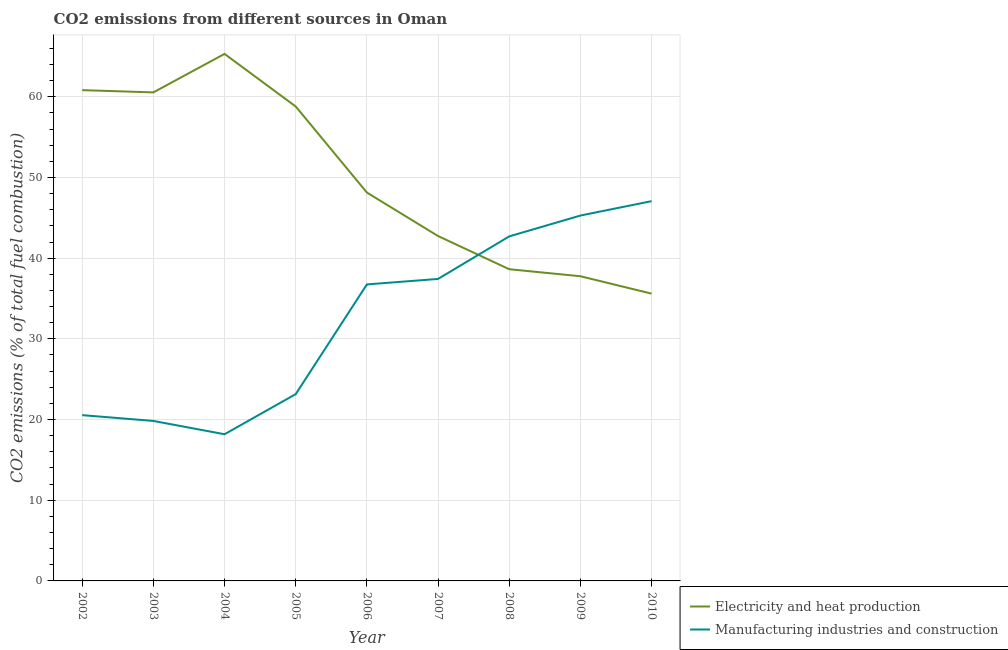What is the co2 emissions due to electricity and heat production in 2004?
Offer a terse response. 65.31. Across all years, what is the maximum co2 emissions due to manufacturing industries?
Keep it short and to the point. 47.06. Across all years, what is the minimum co2 emissions due to electricity and heat production?
Provide a short and direct response. 35.6. What is the total co2 emissions due to electricity and heat production in the graph?
Provide a short and direct response. 448.34. What is the difference between the co2 emissions due to electricity and heat production in 2002 and that in 2010?
Give a very brief answer. 25.22. What is the difference between the co2 emissions due to manufacturing industries in 2004 and the co2 emissions due to electricity and heat production in 2008?
Give a very brief answer. -20.45. What is the average co2 emissions due to manufacturing industries per year?
Keep it short and to the point. 32.32. In the year 2007, what is the difference between the co2 emissions due to manufacturing industries and co2 emissions due to electricity and heat production?
Your response must be concise. -5.31. In how many years, is the co2 emissions due to electricity and heat production greater than 60 %?
Provide a succinct answer. 3. What is the ratio of the co2 emissions due to manufacturing industries in 2005 to that in 2006?
Make the answer very short. 0.63. Is the co2 emissions due to manufacturing industries in 2006 less than that in 2007?
Your answer should be compact. Yes. Is the difference between the co2 emissions due to electricity and heat production in 2003 and 2006 greater than the difference between the co2 emissions due to manufacturing industries in 2003 and 2006?
Offer a very short reply. Yes. What is the difference between the highest and the second highest co2 emissions due to electricity and heat production?
Your answer should be very brief. 4.49. What is the difference between the highest and the lowest co2 emissions due to electricity and heat production?
Ensure brevity in your answer.  29.71. Is the sum of the co2 emissions due to manufacturing industries in 2003 and 2005 greater than the maximum co2 emissions due to electricity and heat production across all years?
Your answer should be compact. No. Does the co2 emissions due to electricity and heat production monotonically increase over the years?
Make the answer very short. No. Is the co2 emissions due to manufacturing industries strictly greater than the co2 emissions due to electricity and heat production over the years?
Provide a succinct answer. No. Is the co2 emissions due to manufacturing industries strictly less than the co2 emissions due to electricity and heat production over the years?
Keep it short and to the point. No. How are the legend labels stacked?
Offer a very short reply. Vertical. What is the title of the graph?
Your answer should be very brief. CO2 emissions from different sources in Oman. What is the label or title of the X-axis?
Offer a terse response. Year. What is the label or title of the Y-axis?
Offer a very short reply. CO2 emissions (% of total fuel combustion). What is the CO2 emissions (% of total fuel combustion) in Electricity and heat production in 2002?
Your answer should be compact. 60.82. What is the CO2 emissions (% of total fuel combustion) of Manufacturing industries and construction in 2002?
Make the answer very short. 20.55. What is the CO2 emissions (% of total fuel combustion) in Electricity and heat production in 2003?
Offer a very short reply. 60.54. What is the CO2 emissions (% of total fuel combustion) of Manufacturing industries and construction in 2003?
Give a very brief answer. 19.83. What is the CO2 emissions (% of total fuel combustion) of Electricity and heat production in 2004?
Provide a short and direct response. 65.31. What is the CO2 emissions (% of total fuel combustion) of Manufacturing industries and construction in 2004?
Provide a succinct answer. 18.18. What is the CO2 emissions (% of total fuel combustion) in Electricity and heat production in 2005?
Keep it short and to the point. 58.8. What is the CO2 emissions (% of total fuel combustion) of Manufacturing industries and construction in 2005?
Offer a very short reply. 23.15. What is the CO2 emissions (% of total fuel combustion) in Electricity and heat production in 2006?
Provide a short and direct response. 48.13. What is the CO2 emissions (% of total fuel combustion) in Manufacturing industries and construction in 2006?
Provide a short and direct response. 36.75. What is the CO2 emissions (% of total fuel combustion) of Electricity and heat production in 2007?
Your response must be concise. 42.74. What is the CO2 emissions (% of total fuel combustion) of Manufacturing industries and construction in 2007?
Give a very brief answer. 37.43. What is the CO2 emissions (% of total fuel combustion) in Electricity and heat production in 2008?
Provide a short and direct response. 38.63. What is the CO2 emissions (% of total fuel combustion) of Manufacturing industries and construction in 2008?
Make the answer very short. 42.7. What is the CO2 emissions (% of total fuel combustion) in Electricity and heat production in 2009?
Offer a terse response. 37.76. What is the CO2 emissions (% of total fuel combustion) of Manufacturing industries and construction in 2009?
Provide a succinct answer. 45.28. What is the CO2 emissions (% of total fuel combustion) in Electricity and heat production in 2010?
Your response must be concise. 35.6. What is the CO2 emissions (% of total fuel combustion) in Manufacturing industries and construction in 2010?
Your answer should be compact. 47.06. Across all years, what is the maximum CO2 emissions (% of total fuel combustion) in Electricity and heat production?
Your answer should be very brief. 65.31. Across all years, what is the maximum CO2 emissions (% of total fuel combustion) in Manufacturing industries and construction?
Provide a succinct answer. 47.06. Across all years, what is the minimum CO2 emissions (% of total fuel combustion) of Electricity and heat production?
Your answer should be very brief. 35.6. Across all years, what is the minimum CO2 emissions (% of total fuel combustion) in Manufacturing industries and construction?
Make the answer very short. 18.18. What is the total CO2 emissions (% of total fuel combustion) in Electricity and heat production in the graph?
Give a very brief answer. 448.34. What is the total CO2 emissions (% of total fuel combustion) of Manufacturing industries and construction in the graph?
Give a very brief answer. 290.92. What is the difference between the CO2 emissions (% of total fuel combustion) of Electricity and heat production in 2002 and that in 2003?
Offer a very short reply. 0.28. What is the difference between the CO2 emissions (% of total fuel combustion) of Manufacturing industries and construction in 2002 and that in 2003?
Offer a very short reply. 0.72. What is the difference between the CO2 emissions (% of total fuel combustion) of Electricity and heat production in 2002 and that in 2004?
Your response must be concise. -4.49. What is the difference between the CO2 emissions (% of total fuel combustion) of Manufacturing industries and construction in 2002 and that in 2004?
Ensure brevity in your answer.  2.37. What is the difference between the CO2 emissions (% of total fuel combustion) in Electricity and heat production in 2002 and that in 2005?
Provide a succinct answer. 2.03. What is the difference between the CO2 emissions (% of total fuel combustion) in Manufacturing industries and construction in 2002 and that in 2005?
Make the answer very short. -2.6. What is the difference between the CO2 emissions (% of total fuel combustion) in Electricity and heat production in 2002 and that in 2006?
Your response must be concise. 12.69. What is the difference between the CO2 emissions (% of total fuel combustion) in Manufacturing industries and construction in 2002 and that in 2006?
Make the answer very short. -16.2. What is the difference between the CO2 emissions (% of total fuel combustion) of Electricity and heat production in 2002 and that in 2007?
Make the answer very short. 18.08. What is the difference between the CO2 emissions (% of total fuel combustion) of Manufacturing industries and construction in 2002 and that in 2007?
Give a very brief answer. -16.88. What is the difference between the CO2 emissions (% of total fuel combustion) of Electricity and heat production in 2002 and that in 2008?
Make the answer very short. 22.19. What is the difference between the CO2 emissions (% of total fuel combustion) of Manufacturing industries and construction in 2002 and that in 2008?
Keep it short and to the point. -22.15. What is the difference between the CO2 emissions (% of total fuel combustion) of Electricity and heat production in 2002 and that in 2009?
Make the answer very short. 23.06. What is the difference between the CO2 emissions (% of total fuel combustion) in Manufacturing industries and construction in 2002 and that in 2009?
Your answer should be compact. -24.73. What is the difference between the CO2 emissions (% of total fuel combustion) of Electricity and heat production in 2002 and that in 2010?
Your response must be concise. 25.22. What is the difference between the CO2 emissions (% of total fuel combustion) of Manufacturing industries and construction in 2002 and that in 2010?
Provide a succinct answer. -26.52. What is the difference between the CO2 emissions (% of total fuel combustion) in Electricity and heat production in 2003 and that in 2004?
Provide a short and direct response. -4.77. What is the difference between the CO2 emissions (% of total fuel combustion) in Manufacturing industries and construction in 2003 and that in 2004?
Offer a very short reply. 1.65. What is the difference between the CO2 emissions (% of total fuel combustion) in Electricity and heat production in 2003 and that in 2005?
Your answer should be compact. 1.75. What is the difference between the CO2 emissions (% of total fuel combustion) in Manufacturing industries and construction in 2003 and that in 2005?
Provide a short and direct response. -3.32. What is the difference between the CO2 emissions (% of total fuel combustion) of Electricity and heat production in 2003 and that in 2006?
Give a very brief answer. 12.41. What is the difference between the CO2 emissions (% of total fuel combustion) in Manufacturing industries and construction in 2003 and that in 2006?
Offer a very short reply. -16.92. What is the difference between the CO2 emissions (% of total fuel combustion) in Electricity and heat production in 2003 and that in 2007?
Provide a succinct answer. 17.8. What is the difference between the CO2 emissions (% of total fuel combustion) of Manufacturing industries and construction in 2003 and that in 2007?
Your answer should be compact. -17.6. What is the difference between the CO2 emissions (% of total fuel combustion) in Electricity and heat production in 2003 and that in 2008?
Provide a succinct answer. 21.91. What is the difference between the CO2 emissions (% of total fuel combustion) of Manufacturing industries and construction in 2003 and that in 2008?
Your response must be concise. -22.87. What is the difference between the CO2 emissions (% of total fuel combustion) of Electricity and heat production in 2003 and that in 2009?
Your answer should be very brief. 22.79. What is the difference between the CO2 emissions (% of total fuel combustion) in Manufacturing industries and construction in 2003 and that in 2009?
Make the answer very short. -25.45. What is the difference between the CO2 emissions (% of total fuel combustion) in Electricity and heat production in 2003 and that in 2010?
Your response must be concise. 24.94. What is the difference between the CO2 emissions (% of total fuel combustion) of Manufacturing industries and construction in 2003 and that in 2010?
Provide a short and direct response. -27.24. What is the difference between the CO2 emissions (% of total fuel combustion) of Electricity and heat production in 2004 and that in 2005?
Ensure brevity in your answer.  6.52. What is the difference between the CO2 emissions (% of total fuel combustion) of Manufacturing industries and construction in 2004 and that in 2005?
Your answer should be compact. -4.97. What is the difference between the CO2 emissions (% of total fuel combustion) of Electricity and heat production in 2004 and that in 2006?
Make the answer very short. 17.18. What is the difference between the CO2 emissions (% of total fuel combustion) in Manufacturing industries and construction in 2004 and that in 2006?
Your answer should be compact. -18.57. What is the difference between the CO2 emissions (% of total fuel combustion) in Electricity and heat production in 2004 and that in 2007?
Offer a terse response. 22.57. What is the difference between the CO2 emissions (% of total fuel combustion) of Manufacturing industries and construction in 2004 and that in 2007?
Provide a short and direct response. -19.25. What is the difference between the CO2 emissions (% of total fuel combustion) in Electricity and heat production in 2004 and that in 2008?
Offer a terse response. 26.68. What is the difference between the CO2 emissions (% of total fuel combustion) in Manufacturing industries and construction in 2004 and that in 2008?
Give a very brief answer. -24.52. What is the difference between the CO2 emissions (% of total fuel combustion) in Electricity and heat production in 2004 and that in 2009?
Make the answer very short. 27.56. What is the difference between the CO2 emissions (% of total fuel combustion) of Manufacturing industries and construction in 2004 and that in 2009?
Make the answer very short. -27.1. What is the difference between the CO2 emissions (% of total fuel combustion) in Electricity and heat production in 2004 and that in 2010?
Make the answer very short. 29.71. What is the difference between the CO2 emissions (% of total fuel combustion) of Manufacturing industries and construction in 2004 and that in 2010?
Your answer should be very brief. -28.89. What is the difference between the CO2 emissions (% of total fuel combustion) of Electricity and heat production in 2005 and that in 2006?
Ensure brevity in your answer.  10.66. What is the difference between the CO2 emissions (% of total fuel combustion) of Manufacturing industries and construction in 2005 and that in 2006?
Keep it short and to the point. -13.6. What is the difference between the CO2 emissions (% of total fuel combustion) of Electricity and heat production in 2005 and that in 2007?
Your answer should be compact. 16.06. What is the difference between the CO2 emissions (% of total fuel combustion) in Manufacturing industries and construction in 2005 and that in 2007?
Provide a succinct answer. -14.28. What is the difference between the CO2 emissions (% of total fuel combustion) in Electricity and heat production in 2005 and that in 2008?
Offer a very short reply. 20.17. What is the difference between the CO2 emissions (% of total fuel combustion) of Manufacturing industries and construction in 2005 and that in 2008?
Your answer should be very brief. -19.55. What is the difference between the CO2 emissions (% of total fuel combustion) in Electricity and heat production in 2005 and that in 2009?
Make the answer very short. 21.04. What is the difference between the CO2 emissions (% of total fuel combustion) of Manufacturing industries and construction in 2005 and that in 2009?
Your response must be concise. -22.13. What is the difference between the CO2 emissions (% of total fuel combustion) of Electricity and heat production in 2005 and that in 2010?
Your answer should be very brief. 23.19. What is the difference between the CO2 emissions (% of total fuel combustion) of Manufacturing industries and construction in 2005 and that in 2010?
Your answer should be compact. -23.92. What is the difference between the CO2 emissions (% of total fuel combustion) in Electricity and heat production in 2006 and that in 2007?
Provide a short and direct response. 5.39. What is the difference between the CO2 emissions (% of total fuel combustion) of Manufacturing industries and construction in 2006 and that in 2007?
Your answer should be very brief. -0.68. What is the difference between the CO2 emissions (% of total fuel combustion) in Electricity and heat production in 2006 and that in 2008?
Your answer should be compact. 9.5. What is the difference between the CO2 emissions (% of total fuel combustion) in Manufacturing industries and construction in 2006 and that in 2008?
Offer a terse response. -5.95. What is the difference between the CO2 emissions (% of total fuel combustion) in Electricity and heat production in 2006 and that in 2009?
Your answer should be very brief. 10.37. What is the difference between the CO2 emissions (% of total fuel combustion) of Manufacturing industries and construction in 2006 and that in 2009?
Offer a terse response. -8.53. What is the difference between the CO2 emissions (% of total fuel combustion) in Electricity and heat production in 2006 and that in 2010?
Give a very brief answer. 12.53. What is the difference between the CO2 emissions (% of total fuel combustion) in Manufacturing industries and construction in 2006 and that in 2010?
Your answer should be very brief. -10.32. What is the difference between the CO2 emissions (% of total fuel combustion) of Electricity and heat production in 2007 and that in 2008?
Make the answer very short. 4.11. What is the difference between the CO2 emissions (% of total fuel combustion) of Manufacturing industries and construction in 2007 and that in 2008?
Make the answer very short. -5.27. What is the difference between the CO2 emissions (% of total fuel combustion) of Electricity and heat production in 2007 and that in 2009?
Offer a terse response. 4.98. What is the difference between the CO2 emissions (% of total fuel combustion) in Manufacturing industries and construction in 2007 and that in 2009?
Give a very brief answer. -7.85. What is the difference between the CO2 emissions (% of total fuel combustion) of Electricity and heat production in 2007 and that in 2010?
Keep it short and to the point. 7.14. What is the difference between the CO2 emissions (% of total fuel combustion) in Manufacturing industries and construction in 2007 and that in 2010?
Ensure brevity in your answer.  -9.64. What is the difference between the CO2 emissions (% of total fuel combustion) of Electricity and heat production in 2008 and that in 2009?
Keep it short and to the point. 0.87. What is the difference between the CO2 emissions (% of total fuel combustion) in Manufacturing industries and construction in 2008 and that in 2009?
Provide a succinct answer. -2.58. What is the difference between the CO2 emissions (% of total fuel combustion) in Electricity and heat production in 2008 and that in 2010?
Your answer should be compact. 3.03. What is the difference between the CO2 emissions (% of total fuel combustion) in Manufacturing industries and construction in 2008 and that in 2010?
Offer a terse response. -4.37. What is the difference between the CO2 emissions (% of total fuel combustion) in Electricity and heat production in 2009 and that in 2010?
Your answer should be very brief. 2.16. What is the difference between the CO2 emissions (% of total fuel combustion) of Manufacturing industries and construction in 2009 and that in 2010?
Your answer should be very brief. -1.78. What is the difference between the CO2 emissions (% of total fuel combustion) of Electricity and heat production in 2002 and the CO2 emissions (% of total fuel combustion) of Manufacturing industries and construction in 2003?
Offer a very short reply. 41. What is the difference between the CO2 emissions (% of total fuel combustion) of Electricity and heat production in 2002 and the CO2 emissions (% of total fuel combustion) of Manufacturing industries and construction in 2004?
Make the answer very short. 42.64. What is the difference between the CO2 emissions (% of total fuel combustion) in Electricity and heat production in 2002 and the CO2 emissions (% of total fuel combustion) in Manufacturing industries and construction in 2005?
Give a very brief answer. 37.67. What is the difference between the CO2 emissions (% of total fuel combustion) in Electricity and heat production in 2002 and the CO2 emissions (% of total fuel combustion) in Manufacturing industries and construction in 2006?
Offer a terse response. 24.08. What is the difference between the CO2 emissions (% of total fuel combustion) in Electricity and heat production in 2002 and the CO2 emissions (% of total fuel combustion) in Manufacturing industries and construction in 2007?
Make the answer very short. 23.4. What is the difference between the CO2 emissions (% of total fuel combustion) in Electricity and heat production in 2002 and the CO2 emissions (% of total fuel combustion) in Manufacturing industries and construction in 2008?
Offer a terse response. 18.12. What is the difference between the CO2 emissions (% of total fuel combustion) in Electricity and heat production in 2002 and the CO2 emissions (% of total fuel combustion) in Manufacturing industries and construction in 2009?
Offer a very short reply. 15.54. What is the difference between the CO2 emissions (% of total fuel combustion) of Electricity and heat production in 2002 and the CO2 emissions (% of total fuel combustion) of Manufacturing industries and construction in 2010?
Offer a very short reply. 13.76. What is the difference between the CO2 emissions (% of total fuel combustion) of Electricity and heat production in 2003 and the CO2 emissions (% of total fuel combustion) of Manufacturing industries and construction in 2004?
Ensure brevity in your answer.  42.37. What is the difference between the CO2 emissions (% of total fuel combustion) of Electricity and heat production in 2003 and the CO2 emissions (% of total fuel combustion) of Manufacturing industries and construction in 2005?
Give a very brief answer. 37.4. What is the difference between the CO2 emissions (% of total fuel combustion) of Electricity and heat production in 2003 and the CO2 emissions (% of total fuel combustion) of Manufacturing industries and construction in 2006?
Keep it short and to the point. 23.8. What is the difference between the CO2 emissions (% of total fuel combustion) of Electricity and heat production in 2003 and the CO2 emissions (% of total fuel combustion) of Manufacturing industries and construction in 2007?
Make the answer very short. 23.12. What is the difference between the CO2 emissions (% of total fuel combustion) in Electricity and heat production in 2003 and the CO2 emissions (% of total fuel combustion) in Manufacturing industries and construction in 2008?
Your answer should be compact. 17.84. What is the difference between the CO2 emissions (% of total fuel combustion) in Electricity and heat production in 2003 and the CO2 emissions (% of total fuel combustion) in Manufacturing industries and construction in 2009?
Your answer should be compact. 15.26. What is the difference between the CO2 emissions (% of total fuel combustion) in Electricity and heat production in 2003 and the CO2 emissions (% of total fuel combustion) in Manufacturing industries and construction in 2010?
Your answer should be compact. 13.48. What is the difference between the CO2 emissions (% of total fuel combustion) of Electricity and heat production in 2004 and the CO2 emissions (% of total fuel combustion) of Manufacturing industries and construction in 2005?
Ensure brevity in your answer.  42.17. What is the difference between the CO2 emissions (% of total fuel combustion) in Electricity and heat production in 2004 and the CO2 emissions (% of total fuel combustion) in Manufacturing industries and construction in 2006?
Offer a terse response. 28.57. What is the difference between the CO2 emissions (% of total fuel combustion) in Electricity and heat production in 2004 and the CO2 emissions (% of total fuel combustion) in Manufacturing industries and construction in 2007?
Give a very brief answer. 27.89. What is the difference between the CO2 emissions (% of total fuel combustion) of Electricity and heat production in 2004 and the CO2 emissions (% of total fuel combustion) of Manufacturing industries and construction in 2008?
Your answer should be very brief. 22.61. What is the difference between the CO2 emissions (% of total fuel combustion) in Electricity and heat production in 2004 and the CO2 emissions (% of total fuel combustion) in Manufacturing industries and construction in 2009?
Give a very brief answer. 20.03. What is the difference between the CO2 emissions (% of total fuel combustion) of Electricity and heat production in 2004 and the CO2 emissions (% of total fuel combustion) of Manufacturing industries and construction in 2010?
Offer a terse response. 18.25. What is the difference between the CO2 emissions (% of total fuel combustion) of Electricity and heat production in 2005 and the CO2 emissions (% of total fuel combustion) of Manufacturing industries and construction in 2006?
Make the answer very short. 22.05. What is the difference between the CO2 emissions (% of total fuel combustion) in Electricity and heat production in 2005 and the CO2 emissions (% of total fuel combustion) in Manufacturing industries and construction in 2007?
Your answer should be compact. 21.37. What is the difference between the CO2 emissions (% of total fuel combustion) of Electricity and heat production in 2005 and the CO2 emissions (% of total fuel combustion) of Manufacturing industries and construction in 2008?
Provide a succinct answer. 16.1. What is the difference between the CO2 emissions (% of total fuel combustion) of Electricity and heat production in 2005 and the CO2 emissions (% of total fuel combustion) of Manufacturing industries and construction in 2009?
Keep it short and to the point. 13.52. What is the difference between the CO2 emissions (% of total fuel combustion) in Electricity and heat production in 2005 and the CO2 emissions (% of total fuel combustion) in Manufacturing industries and construction in 2010?
Keep it short and to the point. 11.73. What is the difference between the CO2 emissions (% of total fuel combustion) in Electricity and heat production in 2006 and the CO2 emissions (% of total fuel combustion) in Manufacturing industries and construction in 2007?
Make the answer very short. 10.71. What is the difference between the CO2 emissions (% of total fuel combustion) of Electricity and heat production in 2006 and the CO2 emissions (% of total fuel combustion) of Manufacturing industries and construction in 2008?
Give a very brief answer. 5.43. What is the difference between the CO2 emissions (% of total fuel combustion) in Electricity and heat production in 2006 and the CO2 emissions (% of total fuel combustion) in Manufacturing industries and construction in 2009?
Your answer should be compact. 2.85. What is the difference between the CO2 emissions (% of total fuel combustion) in Electricity and heat production in 2006 and the CO2 emissions (% of total fuel combustion) in Manufacturing industries and construction in 2010?
Provide a succinct answer. 1.07. What is the difference between the CO2 emissions (% of total fuel combustion) in Electricity and heat production in 2007 and the CO2 emissions (% of total fuel combustion) in Manufacturing industries and construction in 2008?
Provide a short and direct response. 0.04. What is the difference between the CO2 emissions (% of total fuel combustion) of Electricity and heat production in 2007 and the CO2 emissions (% of total fuel combustion) of Manufacturing industries and construction in 2009?
Offer a very short reply. -2.54. What is the difference between the CO2 emissions (% of total fuel combustion) in Electricity and heat production in 2007 and the CO2 emissions (% of total fuel combustion) in Manufacturing industries and construction in 2010?
Your answer should be compact. -4.33. What is the difference between the CO2 emissions (% of total fuel combustion) in Electricity and heat production in 2008 and the CO2 emissions (% of total fuel combustion) in Manufacturing industries and construction in 2009?
Give a very brief answer. -6.65. What is the difference between the CO2 emissions (% of total fuel combustion) in Electricity and heat production in 2008 and the CO2 emissions (% of total fuel combustion) in Manufacturing industries and construction in 2010?
Provide a succinct answer. -8.44. What is the difference between the CO2 emissions (% of total fuel combustion) in Electricity and heat production in 2009 and the CO2 emissions (% of total fuel combustion) in Manufacturing industries and construction in 2010?
Your answer should be very brief. -9.31. What is the average CO2 emissions (% of total fuel combustion) in Electricity and heat production per year?
Provide a succinct answer. 49.82. What is the average CO2 emissions (% of total fuel combustion) of Manufacturing industries and construction per year?
Make the answer very short. 32.32. In the year 2002, what is the difference between the CO2 emissions (% of total fuel combustion) in Electricity and heat production and CO2 emissions (% of total fuel combustion) in Manufacturing industries and construction?
Make the answer very short. 40.28. In the year 2003, what is the difference between the CO2 emissions (% of total fuel combustion) of Electricity and heat production and CO2 emissions (% of total fuel combustion) of Manufacturing industries and construction?
Keep it short and to the point. 40.72. In the year 2004, what is the difference between the CO2 emissions (% of total fuel combustion) in Electricity and heat production and CO2 emissions (% of total fuel combustion) in Manufacturing industries and construction?
Your response must be concise. 47.14. In the year 2005, what is the difference between the CO2 emissions (% of total fuel combustion) of Electricity and heat production and CO2 emissions (% of total fuel combustion) of Manufacturing industries and construction?
Give a very brief answer. 35.65. In the year 2006, what is the difference between the CO2 emissions (% of total fuel combustion) in Electricity and heat production and CO2 emissions (% of total fuel combustion) in Manufacturing industries and construction?
Your response must be concise. 11.39. In the year 2007, what is the difference between the CO2 emissions (% of total fuel combustion) in Electricity and heat production and CO2 emissions (% of total fuel combustion) in Manufacturing industries and construction?
Your response must be concise. 5.31. In the year 2008, what is the difference between the CO2 emissions (% of total fuel combustion) in Electricity and heat production and CO2 emissions (% of total fuel combustion) in Manufacturing industries and construction?
Provide a short and direct response. -4.07. In the year 2009, what is the difference between the CO2 emissions (% of total fuel combustion) in Electricity and heat production and CO2 emissions (% of total fuel combustion) in Manufacturing industries and construction?
Ensure brevity in your answer.  -7.52. In the year 2010, what is the difference between the CO2 emissions (% of total fuel combustion) in Electricity and heat production and CO2 emissions (% of total fuel combustion) in Manufacturing industries and construction?
Ensure brevity in your answer.  -11.46. What is the ratio of the CO2 emissions (% of total fuel combustion) of Electricity and heat production in 2002 to that in 2003?
Your response must be concise. 1. What is the ratio of the CO2 emissions (% of total fuel combustion) in Manufacturing industries and construction in 2002 to that in 2003?
Offer a terse response. 1.04. What is the ratio of the CO2 emissions (% of total fuel combustion) of Electricity and heat production in 2002 to that in 2004?
Give a very brief answer. 0.93. What is the ratio of the CO2 emissions (% of total fuel combustion) of Manufacturing industries and construction in 2002 to that in 2004?
Keep it short and to the point. 1.13. What is the ratio of the CO2 emissions (% of total fuel combustion) of Electricity and heat production in 2002 to that in 2005?
Your answer should be very brief. 1.03. What is the ratio of the CO2 emissions (% of total fuel combustion) in Manufacturing industries and construction in 2002 to that in 2005?
Offer a terse response. 0.89. What is the ratio of the CO2 emissions (% of total fuel combustion) in Electricity and heat production in 2002 to that in 2006?
Make the answer very short. 1.26. What is the ratio of the CO2 emissions (% of total fuel combustion) in Manufacturing industries and construction in 2002 to that in 2006?
Keep it short and to the point. 0.56. What is the ratio of the CO2 emissions (% of total fuel combustion) in Electricity and heat production in 2002 to that in 2007?
Give a very brief answer. 1.42. What is the ratio of the CO2 emissions (% of total fuel combustion) in Manufacturing industries and construction in 2002 to that in 2007?
Give a very brief answer. 0.55. What is the ratio of the CO2 emissions (% of total fuel combustion) in Electricity and heat production in 2002 to that in 2008?
Offer a very short reply. 1.57. What is the ratio of the CO2 emissions (% of total fuel combustion) in Manufacturing industries and construction in 2002 to that in 2008?
Make the answer very short. 0.48. What is the ratio of the CO2 emissions (% of total fuel combustion) in Electricity and heat production in 2002 to that in 2009?
Your answer should be compact. 1.61. What is the ratio of the CO2 emissions (% of total fuel combustion) of Manufacturing industries and construction in 2002 to that in 2009?
Your response must be concise. 0.45. What is the ratio of the CO2 emissions (% of total fuel combustion) in Electricity and heat production in 2002 to that in 2010?
Offer a terse response. 1.71. What is the ratio of the CO2 emissions (% of total fuel combustion) of Manufacturing industries and construction in 2002 to that in 2010?
Provide a succinct answer. 0.44. What is the ratio of the CO2 emissions (% of total fuel combustion) in Electricity and heat production in 2003 to that in 2004?
Offer a terse response. 0.93. What is the ratio of the CO2 emissions (% of total fuel combustion) of Manufacturing industries and construction in 2003 to that in 2004?
Give a very brief answer. 1.09. What is the ratio of the CO2 emissions (% of total fuel combustion) in Electricity and heat production in 2003 to that in 2005?
Your answer should be compact. 1.03. What is the ratio of the CO2 emissions (% of total fuel combustion) in Manufacturing industries and construction in 2003 to that in 2005?
Give a very brief answer. 0.86. What is the ratio of the CO2 emissions (% of total fuel combustion) of Electricity and heat production in 2003 to that in 2006?
Your response must be concise. 1.26. What is the ratio of the CO2 emissions (% of total fuel combustion) of Manufacturing industries and construction in 2003 to that in 2006?
Your answer should be compact. 0.54. What is the ratio of the CO2 emissions (% of total fuel combustion) in Electricity and heat production in 2003 to that in 2007?
Your answer should be very brief. 1.42. What is the ratio of the CO2 emissions (% of total fuel combustion) of Manufacturing industries and construction in 2003 to that in 2007?
Ensure brevity in your answer.  0.53. What is the ratio of the CO2 emissions (% of total fuel combustion) of Electricity and heat production in 2003 to that in 2008?
Your answer should be very brief. 1.57. What is the ratio of the CO2 emissions (% of total fuel combustion) in Manufacturing industries and construction in 2003 to that in 2008?
Provide a short and direct response. 0.46. What is the ratio of the CO2 emissions (% of total fuel combustion) of Electricity and heat production in 2003 to that in 2009?
Your answer should be compact. 1.6. What is the ratio of the CO2 emissions (% of total fuel combustion) in Manufacturing industries and construction in 2003 to that in 2009?
Your response must be concise. 0.44. What is the ratio of the CO2 emissions (% of total fuel combustion) of Electricity and heat production in 2003 to that in 2010?
Offer a terse response. 1.7. What is the ratio of the CO2 emissions (% of total fuel combustion) in Manufacturing industries and construction in 2003 to that in 2010?
Offer a very short reply. 0.42. What is the ratio of the CO2 emissions (% of total fuel combustion) of Electricity and heat production in 2004 to that in 2005?
Your answer should be very brief. 1.11. What is the ratio of the CO2 emissions (% of total fuel combustion) of Manufacturing industries and construction in 2004 to that in 2005?
Keep it short and to the point. 0.79. What is the ratio of the CO2 emissions (% of total fuel combustion) of Electricity and heat production in 2004 to that in 2006?
Make the answer very short. 1.36. What is the ratio of the CO2 emissions (% of total fuel combustion) in Manufacturing industries and construction in 2004 to that in 2006?
Your answer should be compact. 0.49. What is the ratio of the CO2 emissions (% of total fuel combustion) in Electricity and heat production in 2004 to that in 2007?
Provide a succinct answer. 1.53. What is the ratio of the CO2 emissions (% of total fuel combustion) of Manufacturing industries and construction in 2004 to that in 2007?
Your response must be concise. 0.49. What is the ratio of the CO2 emissions (% of total fuel combustion) in Electricity and heat production in 2004 to that in 2008?
Your response must be concise. 1.69. What is the ratio of the CO2 emissions (% of total fuel combustion) in Manufacturing industries and construction in 2004 to that in 2008?
Offer a terse response. 0.43. What is the ratio of the CO2 emissions (% of total fuel combustion) of Electricity and heat production in 2004 to that in 2009?
Keep it short and to the point. 1.73. What is the ratio of the CO2 emissions (% of total fuel combustion) in Manufacturing industries and construction in 2004 to that in 2009?
Your answer should be compact. 0.4. What is the ratio of the CO2 emissions (% of total fuel combustion) in Electricity and heat production in 2004 to that in 2010?
Keep it short and to the point. 1.83. What is the ratio of the CO2 emissions (% of total fuel combustion) of Manufacturing industries and construction in 2004 to that in 2010?
Your answer should be very brief. 0.39. What is the ratio of the CO2 emissions (% of total fuel combustion) of Electricity and heat production in 2005 to that in 2006?
Your answer should be very brief. 1.22. What is the ratio of the CO2 emissions (% of total fuel combustion) of Manufacturing industries and construction in 2005 to that in 2006?
Ensure brevity in your answer.  0.63. What is the ratio of the CO2 emissions (% of total fuel combustion) in Electricity and heat production in 2005 to that in 2007?
Give a very brief answer. 1.38. What is the ratio of the CO2 emissions (% of total fuel combustion) of Manufacturing industries and construction in 2005 to that in 2007?
Offer a very short reply. 0.62. What is the ratio of the CO2 emissions (% of total fuel combustion) of Electricity and heat production in 2005 to that in 2008?
Give a very brief answer. 1.52. What is the ratio of the CO2 emissions (% of total fuel combustion) of Manufacturing industries and construction in 2005 to that in 2008?
Your response must be concise. 0.54. What is the ratio of the CO2 emissions (% of total fuel combustion) in Electricity and heat production in 2005 to that in 2009?
Your answer should be very brief. 1.56. What is the ratio of the CO2 emissions (% of total fuel combustion) of Manufacturing industries and construction in 2005 to that in 2009?
Make the answer very short. 0.51. What is the ratio of the CO2 emissions (% of total fuel combustion) in Electricity and heat production in 2005 to that in 2010?
Provide a succinct answer. 1.65. What is the ratio of the CO2 emissions (% of total fuel combustion) of Manufacturing industries and construction in 2005 to that in 2010?
Ensure brevity in your answer.  0.49. What is the ratio of the CO2 emissions (% of total fuel combustion) of Electricity and heat production in 2006 to that in 2007?
Make the answer very short. 1.13. What is the ratio of the CO2 emissions (% of total fuel combustion) in Manufacturing industries and construction in 2006 to that in 2007?
Your response must be concise. 0.98. What is the ratio of the CO2 emissions (% of total fuel combustion) in Electricity and heat production in 2006 to that in 2008?
Your answer should be compact. 1.25. What is the ratio of the CO2 emissions (% of total fuel combustion) of Manufacturing industries and construction in 2006 to that in 2008?
Give a very brief answer. 0.86. What is the ratio of the CO2 emissions (% of total fuel combustion) in Electricity and heat production in 2006 to that in 2009?
Ensure brevity in your answer.  1.27. What is the ratio of the CO2 emissions (% of total fuel combustion) of Manufacturing industries and construction in 2006 to that in 2009?
Keep it short and to the point. 0.81. What is the ratio of the CO2 emissions (% of total fuel combustion) of Electricity and heat production in 2006 to that in 2010?
Provide a succinct answer. 1.35. What is the ratio of the CO2 emissions (% of total fuel combustion) in Manufacturing industries and construction in 2006 to that in 2010?
Provide a short and direct response. 0.78. What is the ratio of the CO2 emissions (% of total fuel combustion) of Electricity and heat production in 2007 to that in 2008?
Provide a short and direct response. 1.11. What is the ratio of the CO2 emissions (% of total fuel combustion) in Manufacturing industries and construction in 2007 to that in 2008?
Offer a very short reply. 0.88. What is the ratio of the CO2 emissions (% of total fuel combustion) in Electricity and heat production in 2007 to that in 2009?
Offer a terse response. 1.13. What is the ratio of the CO2 emissions (% of total fuel combustion) in Manufacturing industries and construction in 2007 to that in 2009?
Offer a terse response. 0.83. What is the ratio of the CO2 emissions (% of total fuel combustion) in Electricity and heat production in 2007 to that in 2010?
Make the answer very short. 1.2. What is the ratio of the CO2 emissions (% of total fuel combustion) of Manufacturing industries and construction in 2007 to that in 2010?
Your answer should be very brief. 0.8. What is the ratio of the CO2 emissions (% of total fuel combustion) in Electricity and heat production in 2008 to that in 2009?
Offer a very short reply. 1.02. What is the ratio of the CO2 emissions (% of total fuel combustion) of Manufacturing industries and construction in 2008 to that in 2009?
Your answer should be very brief. 0.94. What is the ratio of the CO2 emissions (% of total fuel combustion) of Electricity and heat production in 2008 to that in 2010?
Offer a very short reply. 1.08. What is the ratio of the CO2 emissions (% of total fuel combustion) in Manufacturing industries and construction in 2008 to that in 2010?
Give a very brief answer. 0.91. What is the ratio of the CO2 emissions (% of total fuel combustion) in Electricity and heat production in 2009 to that in 2010?
Ensure brevity in your answer.  1.06. What is the ratio of the CO2 emissions (% of total fuel combustion) in Manufacturing industries and construction in 2009 to that in 2010?
Provide a short and direct response. 0.96. What is the difference between the highest and the second highest CO2 emissions (% of total fuel combustion) of Electricity and heat production?
Provide a succinct answer. 4.49. What is the difference between the highest and the second highest CO2 emissions (% of total fuel combustion) of Manufacturing industries and construction?
Offer a terse response. 1.78. What is the difference between the highest and the lowest CO2 emissions (% of total fuel combustion) of Electricity and heat production?
Your answer should be very brief. 29.71. What is the difference between the highest and the lowest CO2 emissions (% of total fuel combustion) of Manufacturing industries and construction?
Provide a short and direct response. 28.89. 